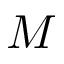Convert formula to latex. <formula><loc_0><loc_0><loc_500><loc_500>M</formula> 